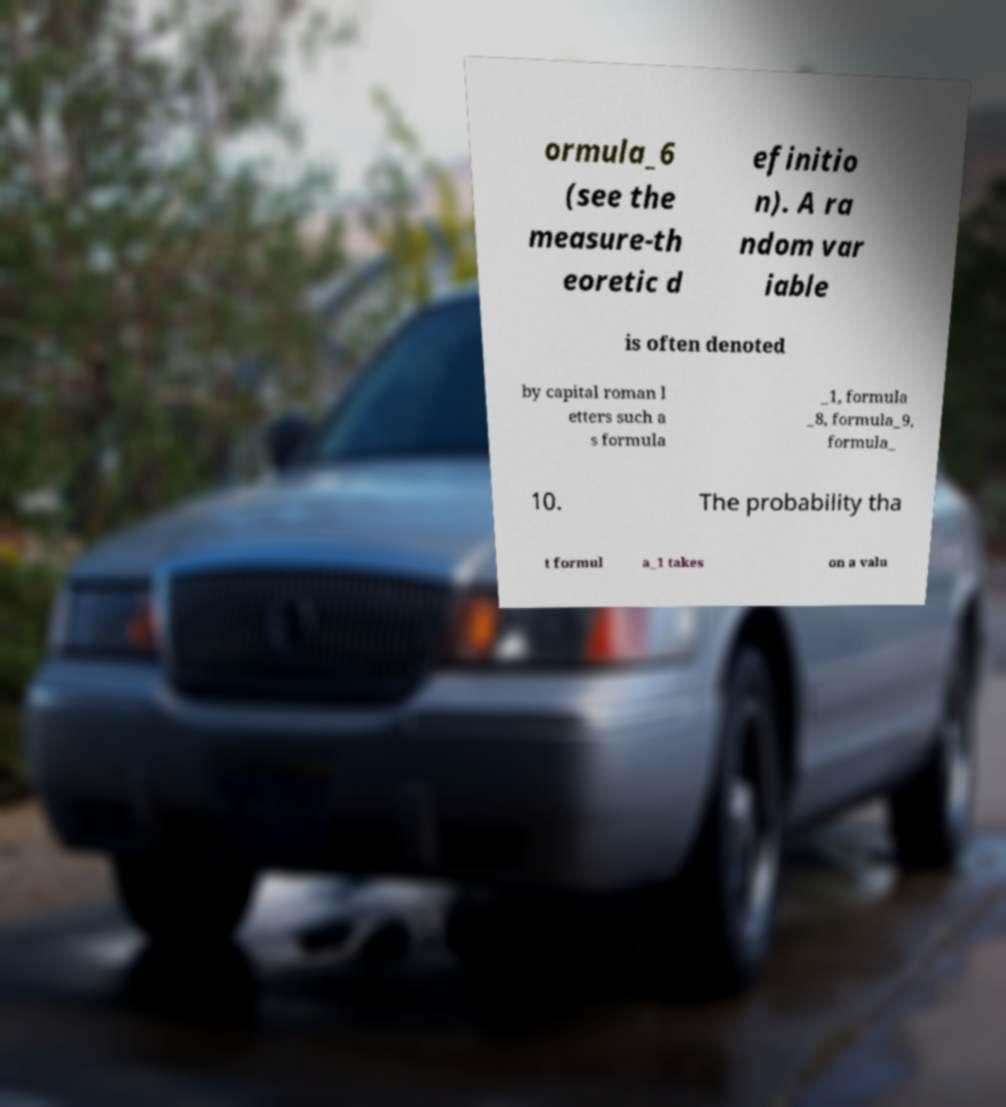Can you read and provide the text displayed in the image?This photo seems to have some interesting text. Can you extract and type it out for me? ormula_6 (see the measure-th eoretic d efinitio n). A ra ndom var iable is often denoted by capital roman l etters such a s formula _1, formula _8, formula_9, formula_ 10. The probability tha t formul a_1 takes on a valu 